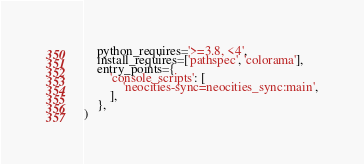<code> <loc_0><loc_0><loc_500><loc_500><_Python_>    python_requires='>=3.8, <4',
    install_requires=['pathspec', 'colorama'],
    entry_points={
        'console_scripts': [
            'neocities-sync=neocities_sync:main',
        ],
    },
)
</code> 